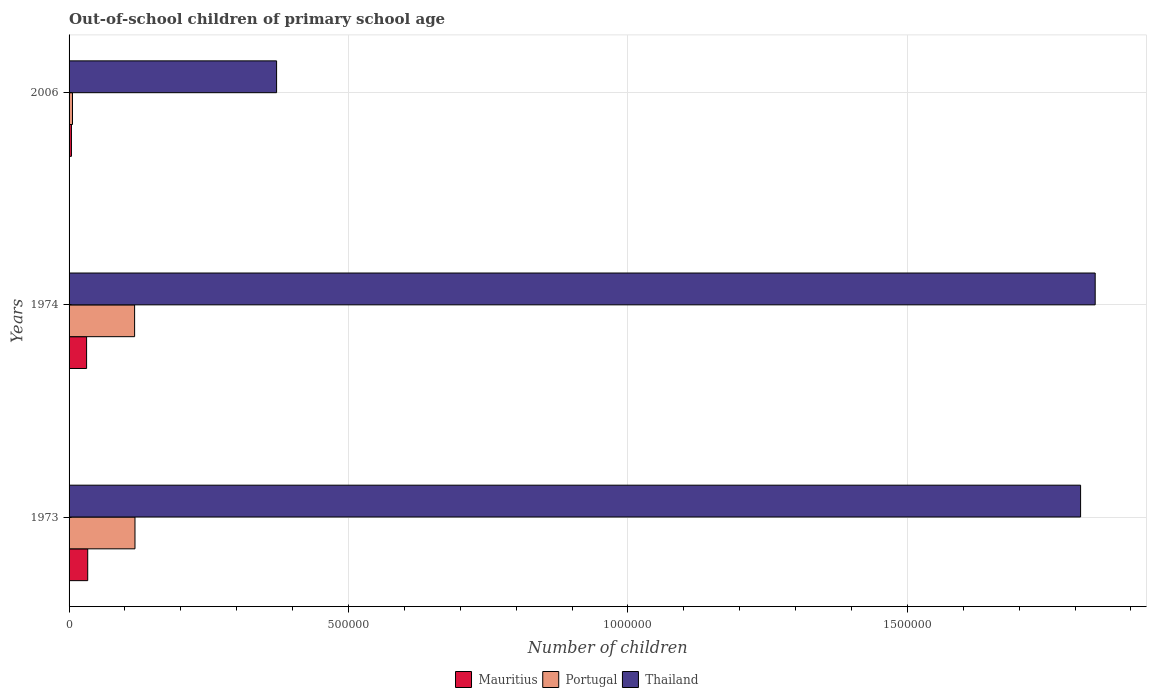How many bars are there on the 1st tick from the top?
Give a very brief answer. 3. What is the label of the 2nd group of bars from the top?
Provide a short and direct response. 1974. In how many cases, is the number of bars for a given year not equal to the number of legend labels?
Provide a short and direct response. 0. What is the number of out-of-school children in Thailand in 1974?
Make the answer very short. 1.84e+06. Across all years, what is the maximum number of out-of-school children in Mauritius?
Your answer should be very brief. 3.34e+04. Across all years, what is the minimum number of out-of-school children in Portugal?
Offer a terse response. 6100. In which year was the number of out-of-school children in Thailand maximum?
Provide a succinct answer. 1974. In which year was the number of out-of-school children in Thailand minimum?
Provide a short and direct response. 2006. What is the total number of out-of-school children in Mauritius in the graph?
Offer a very short reply. 6.90e+04. What is the difference between the number of out-of-school children in Portugal in 1973 and that in 1974?
Give a very brief answer. 678. What is the difference between the number of out-of-school children in Thailand in 1973 and the number of out-of-school children in Mauritius in 1974?
Provide a succinct answer. 1.78e+06. What is the average number of out-of-school children in Thailand per year?
Your response must be concise. 1.34e+06. In the year 2006, what is the difference between the number of out-of-school children in Thailand and number of out-of-school children in Mauritius?
Ensure brevity in your answer.  3.67e+05. In how many years, is the number of out-of-school children in Portugal greater than 100000 ?
Your answer should be compact. 2. What is the ratio of the number of out-of-school children in Thailand in 1974 to that in 2006?
Your answer should be very brief. 4.94. What is the difference between the highest and the second highest number of out-of-school children in Mauritius?
Ensure brevity in your answer.  2016. What is the difference between the highest and the lowest number of out-of-school children in Portugal?
Provide a succinct answer. 1.12e+05. In how many years, is the number of out-of-school children in Mauritius greater than the average number of out-of-school children in Mauritius taken over all years?
Provide a succinct answer. 2. Is the sum of the number of out-of-school children in Thailand in 1973 and 1974 greater than the maximum number of out-of-school children in Mauritius across all years?
Your answer should be very brief. Yes. What does the 1st bar from the top in 1973 represents?
Your answer should be very brief. Thailand. Is it the case that in every year, the sum of the number of out-of-school children in Thailand and number of out-of-school children in Portugal is greater than the number of out-of-school children in Mauritius?
Your answer should be compact. Yes. How many bars are there?
Keep it short and to the point. 9. Are all the bars in the graph horizontal?
Keep it short and to the point. Yes. How many years are there in the graph?
Ensure brevity in your answer.  3. Are the values on the major ticks of X-axis written in scientific E-notation?
Offer a terse response. No. Does the graph contain any zero values?
Give a very brief answer. No. Does the graph contain grids?
Ensure brevity in your answer.  Yes. How many legend labels are there?
Your answer should be very brief. 3. What is the title of the graph?
Make the answer very short. Out-of-school children of primary school age. Does "Low income" appear as one of the legend labels in the graph?
Provide a succinct answer. No. What is the label or title of the X-axis?
Offer a very short reply. Number of children. What is the Number of children in Mauritius in 1973?
Give a very brief answer. 3.34e+04. What is the Number of children in Portugal in 1973?
Your response must be concise. 1.18e+05. What is the Number of children in Thailand in 1973?
Offer a terse response. 1.81e+06. What is the Number of children of Mauritius in 1974?
Provide a short and direct response. 3.14e+04. What is the Number of children in Portugal in 1974?
Your response must be concise. 1.17e+05. What is the Number of children of Thailand in 1974?
Give a very brief answer. 1.84e+06. What is the Number of children of Mauritius in 2006?
Your answer should be compact. 4245. What is the Number of children of Portugal in 2006?
Your answer should be very brief. 6100. What is the Number of children of Thailand in 2006?
Give a very brief answer. 3.71e+05. Across all years, what is the maximum Number of children of Mauritius?
Provide a succinct answer. 3.34e+04. Across all years, what is the maximum Number of children in Portugal?
Ensure brevity in your answer.  1.18e+05. Across all years, what is the maximum Number of children of Thailand?
Keep it short and to the point. 1.84e+06. Across all years, what is the minimum Number of children in Mauritius?
Offer a terse response. 4245. Across all years, what is the minimum Number of children of Portugal?
Offer a terse response. 6100. Across all years, what is the minimum Number of children in Thailand?
Ensure brevity in your answer.  3.71e+05. What is the total Number of children in Mauritius in the graph?
Your answer should be compact. 6.90e+04. What is the total Number of children in Portugal in the graph?
Provide a short and direct response. 2.41e+05. What is the total Number of children in Thailand in the graph?
Offer a very short reply. 4.02e+06. What is the difference between the Number of children in Mauritius in 1973 and that in 1974?
Offer a very short reply. 2016. What is the difference between the Number of children of Portugal in 1973 and that in 1974?
Ensure brevity in your answer.  678. What is the difference between the Number of children in Thailand in 1973 and that in 1974?
Keep it short and to the point. -2.61e+04. What is the difference between the Number of children of Mauritius in 1973 and that in 2006?
Your answer should be compact. 2.91e+04. What is the difference between the Number of children in Portugal in 1973 and that in 2006?
Your answer should be compact. 1.12e+05. What is the difference between the Number of children of Thailand in 1973 and that in 2006?
Provide a short and direct response. 1.44e+06. What is the difference between the Number of children in Mauritius in 1974 and that in 2006?
Keep it short and to the point. 2.71e+04. What is the difference between the Number of children in Portugal in 1974 and that in 2006?
Offer a very short reply. 1.11e+05. What is the difference between the Number of children of Thailand in 1974 and that in 2006?
Offer a very short reply. 1.46e+06. What is the difference between the Number of children in Mauritius in 1973 and the Number of children in Portugal in 1974?
Your response must be concise. -8.39e+04. What is the difference between the Number of children in Mauritius in 1973 and the Number of children in Thailand in 1974?
Keep it short and to the point. -1.80e+06. What is the difference between the Number of children in Portugal in 1973 and the Number of children in Thailand in 1974?
Your response must be concise. -1.72e+06. What is the difference between the Number of children of Mauritius in 1973 and the Number of children of Portugal in 2006?
Provide a short and direct response. 2.73e+04. What is the difference between the Number of children in Mauritius in 1973 and the Number of children in Thailand in 2006?
Your response must be concise. -3.38e+05. What is the difference between the Number of children in Portugal in 1973 and the Number of children in Thailand in 2006?
Provide a succinct answer. -2.53e+05. What is the difference between the Number of children in Mauritius in 1974 and the Number of children in Portugal in 2006?
Give a very brief answer. 2.53e+04. What is the difference between the Number of children of Mauritius in 1974 and the Number of children of Thailand in 2006?
Your response must be concise. -3.40e+05. What is the difference between the Number of children in Portugal in 1974 and the Number of children in Thailand in 2006?
Make the answer very short. -2.54e+05. What is the average Number of children of Mauritius per year?
Your answer should be compact. 2.30e+04. What is the average Number of children of Portugal per year?
Your response must be concise. 8.04e+04. What is the average Number of children of Thailand per year?
Ensure brevity in your answer.  1.34e+06. In the year 1973, what is the difference between the Number of children of Mauritius and Number of children of Portugal?
Provide a succinct answer. -8.46e+04. In the year 1973, what is the difference between the Number of children in Mauritius and Number of children in Thailand?
Ensure brevity in your answer.  -1.78e+06. In the year 1973, what is the difference between the Number of children of Portugal and Number of children of Thailand?
Provide a succinct answer. -1.69e+06. In the year 1974, what is the difference between the Number of children of Mauritius and Number of children of Portugal?
Provide a succinct answer. -8.59e+04. In the year 1974, what is the difference between the Number of children in Mauritius and Number of children in Thailand?
Offer a terse response. -1.80e+06. In the year 1974, what is the difference between the Number of children of Portugal and Number of children of Thailand?
Your answer should be very brief. -1.72e+06. In the year 2006, what is the difference between the Number of children of Mauritius and Number of children of Portugal?
Your answer should be compact. -1855. In the year 2006, what is the difference between the Number of children of Mauritius and Number of children of Thailand?
Your response must be concise. -3.67e+05. In the year 2006, what is the difference between the Number of children in Portugal and Number of children in Thailand?
Your response must be concise. -3.65e+05. What is the ratio of the Number of children of Mauritius in 1973 to that in 1974?
Provide a short and direct response. 1.06. What is the ratio of the Number of children in Thailand in 1973 to that in 1974?
Your answer should be compact. 0.99. What is the ratio of the Number of children in Mauritius in 1973 to that in 2006?
Offer a terse response. 7.86. What is the ratio of the Number of children in Portugal in 1973 to that in 2006?
Provide a short and direct response. 19.33. What is the ratio of the Number of children of Thailand in 1973 to that in 2006?
Offer a very short reply. 4.87. What is the ratio of the Number of children of Mauritius in 1974 to that in 2006?
Make the answer very short. 7.39. What is the ratio of the Number of children of Portugal in 1974 to that in 2006?
Provide a succinct answer. 19.22. What is the ratio of the Number of children of Thailand in 1974 to that in 2006?
Offer a terse response. 4.94. What is the difference between the highest and the second highest Number of children in Mauritius?
Offer a very short reply. 2016. What is the difference between the highest and the second highest Number of children in Portugal?
Offer a very short reply. 678. What is the difference between the highest and the second highest Number of children in Thailand?
Offer a terse response. 2.61e+04. What is the difference between the highest and the lowest Number of children of Mauritius?
Ensure brevity in your answer.  2.91e+04. What is the difference between the highest and the lowest Number of children in Portugal?
Your answer should be compact. 1.12e+05. What is the difference between the highest and the lowest Number of children of Thailand?
Give a very brief answer. 1.46e+06. 